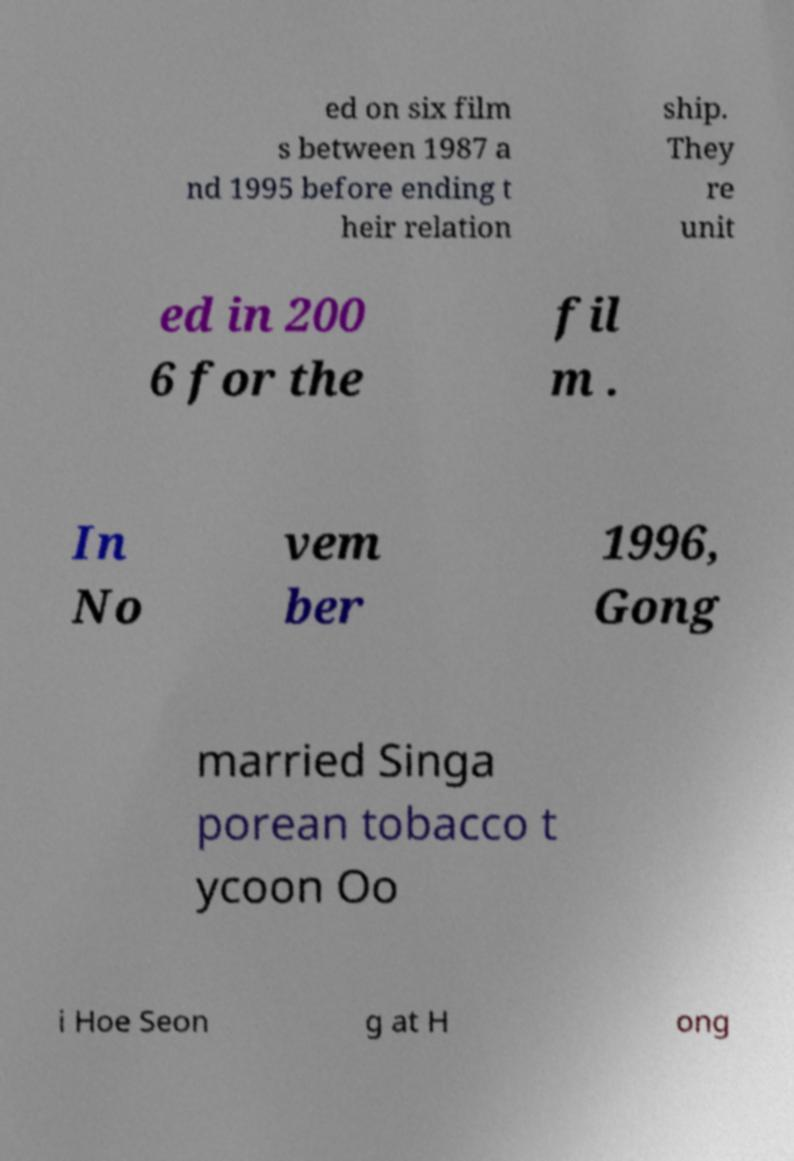For documentation purposes, I need the text within this image transcribed. Could you provide that? ed on six film s between 1987 a nd 1995 before ending t heir relation ship. They re unit ed in 200 6 for the fil m . In No vem ber 1996, Gong married Singa porean tobacco t ycoon Oo i Hoe Seon g at H ong 